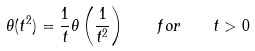<formula> <loc_0><loc_0><loc_500><loc_500>\theta ( t ^ { 2 } ) = \frac { 1 } { t } \theta \left ( \frac { 1 } { t ^ { 2 } } \right ) \quad f o r \quad t > 0</formula> 